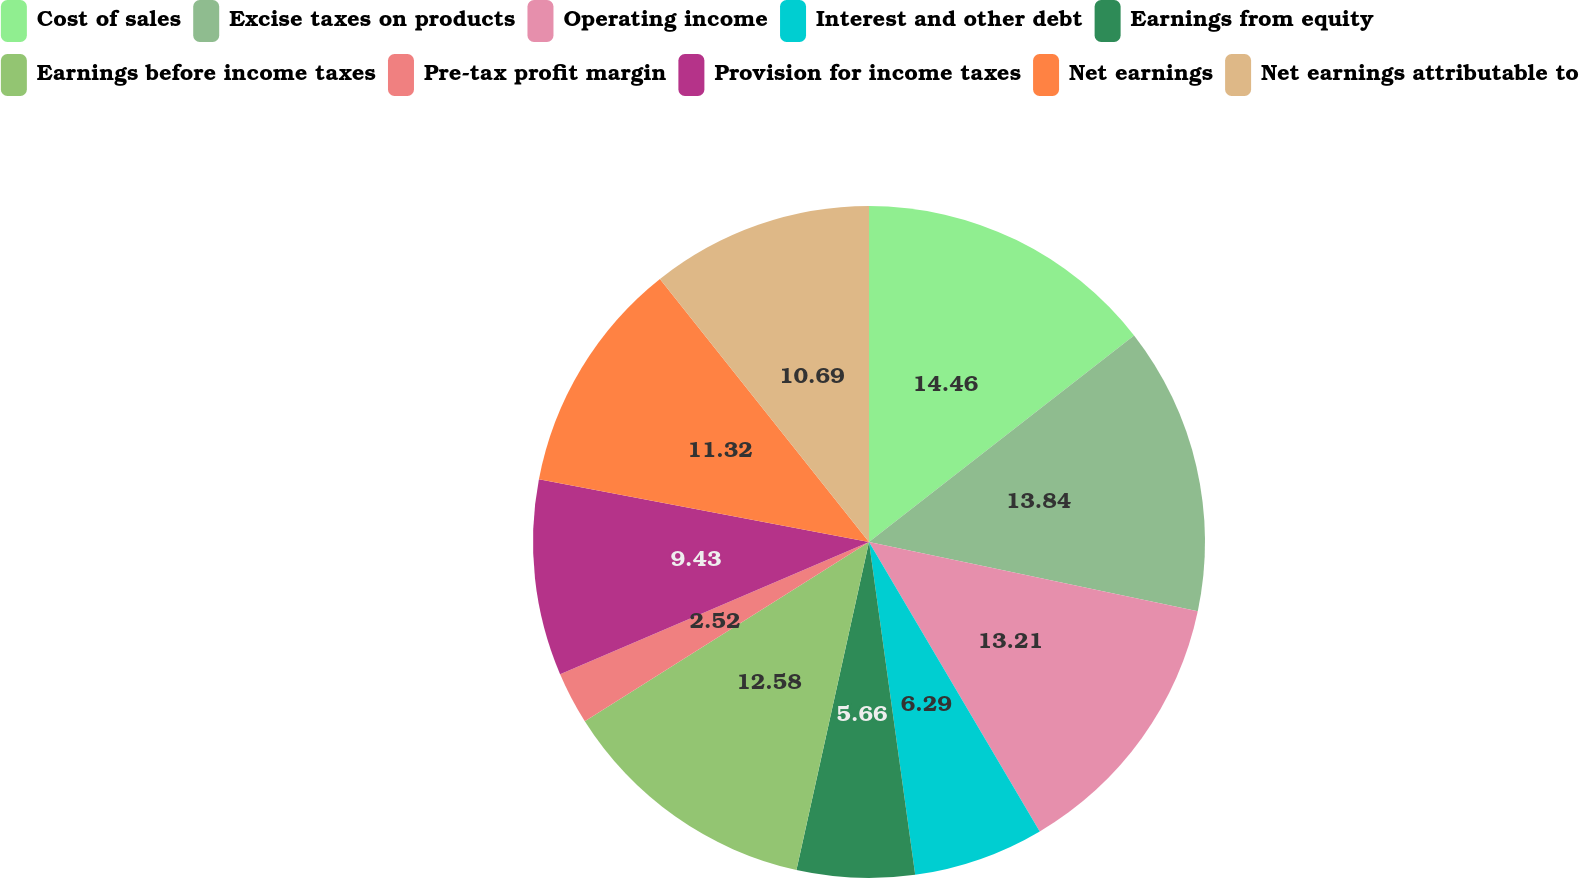<chart> <loc_0><loc_0><loc_500><loc_500><pie_chart><fcel>Cost of sales<fcel>Excise taxes on products<fcel>Operating income<fcel>Interest and other debt<fcel>Earnings from equity<fcel>Earnings before income taxes<fcel>Pre-tax profit margin<fcel>Provision for income taxes<fcel>Net earnings<fcel>Net earnings attributable to<nl><fcel>14.47%<fcel>13.84%<fcel>13.21%<fcel>6.29%<fcel>5.66%<fcel>12.58%<fcel>2.52%<fcel>9.43%<fcel>11.32%<fcel>10.69%<nl></chart> 